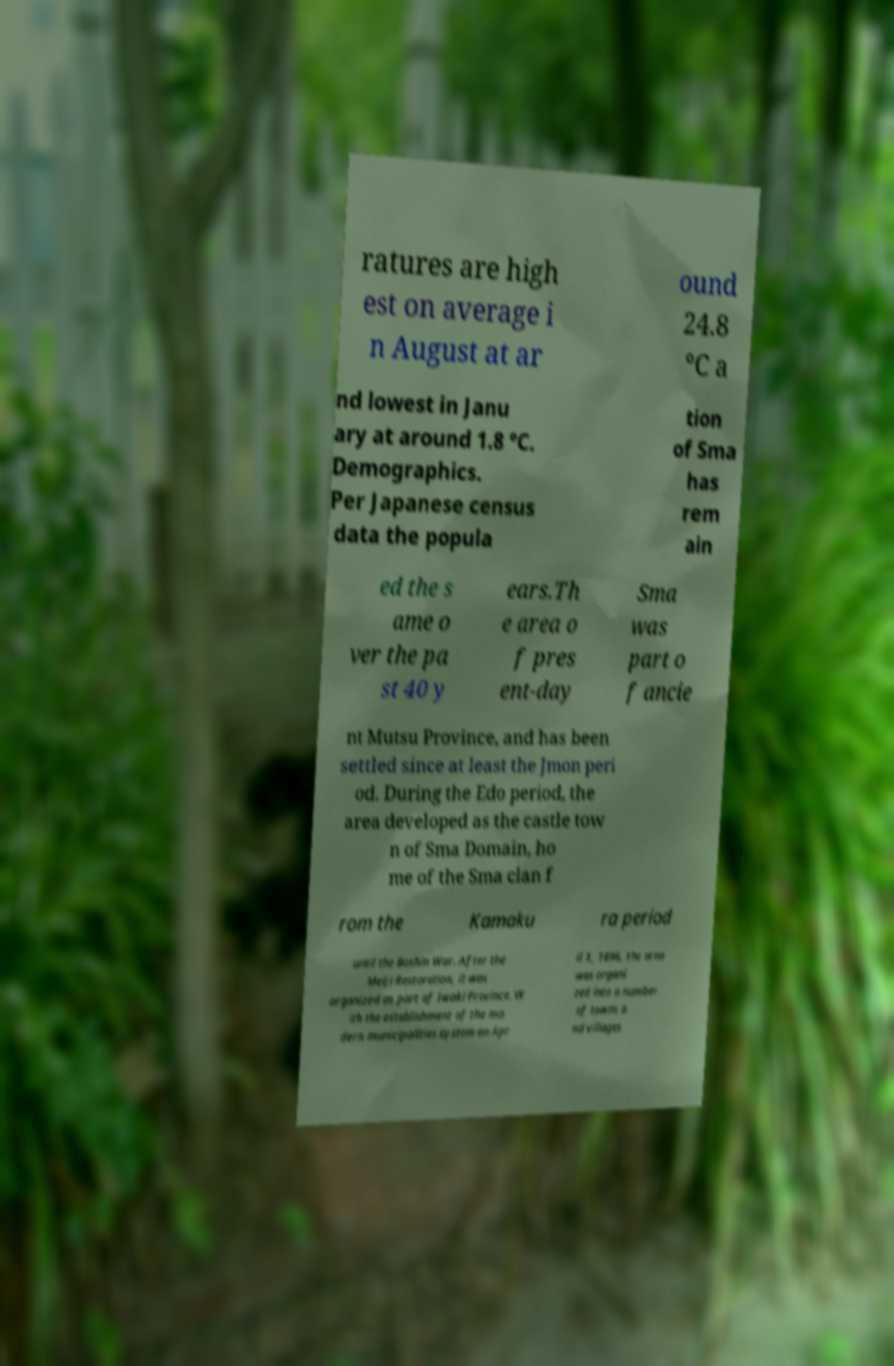Please read and relay the text visible in this image. What does it say? ratures are high est on average i n August at ar ound 24.8 °C a nd lowest in Janu ary at around 1.8 °C. Demographics. Per Japanese census data the popula tion of Sma has rem ain ed the s ame o ver the pa st 40 y ears.Th e area o f pres ent-day Sma was part o f ancie nt Mutsu Province, and has been settled since at least the Jmon peri od. During the Edo period, the area developed as the castle tow n of Sma Domain, ho me of the Sma clan f rom the Kamaku ra period until the Boshin War. After the Meiji Restoration, it was organized as part of Iwaki Province. W ith the establishment of the mo dern municipalities system on Apr il 1, 1896, the area was organi zed into a number of towns a nd villages 